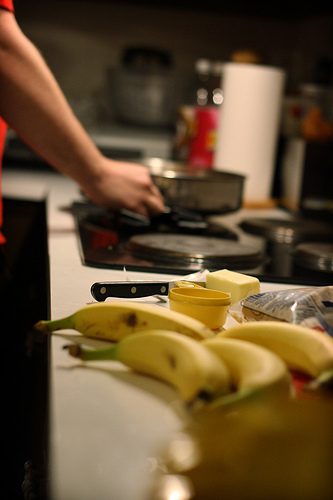What time of day do you think it is in the image given the lighting and activity? The intimate indoor lighting and the activity suggest it might be early morning, a common time for preparing breakfast. 